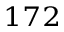<formula> <loc_0><loc_0><loc_500><loc_500>^ { 1 7 2 }</formula> 